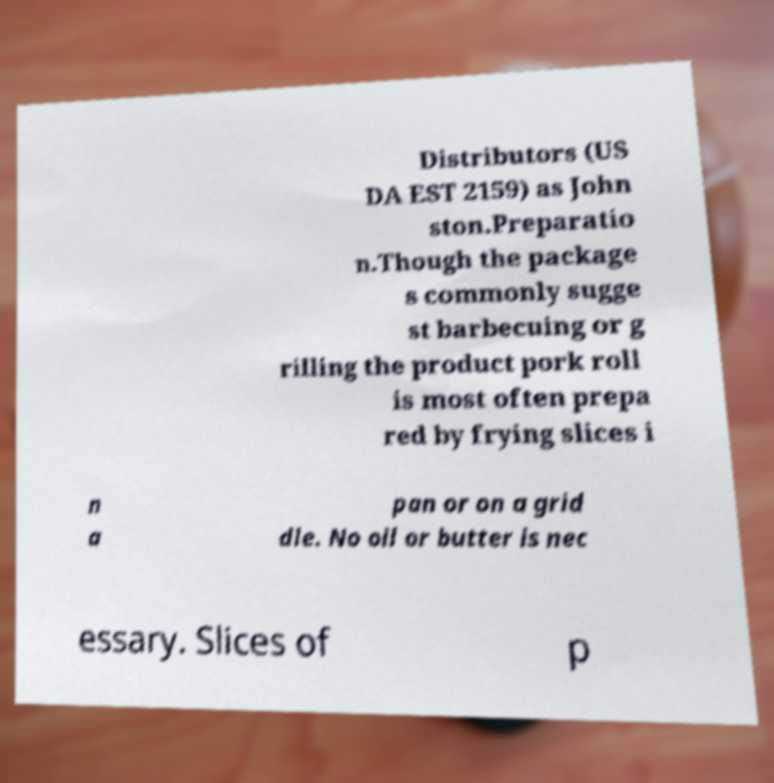Please read and relay the text visible in this image. What does it say? Distributors (US DA EST 2159) as John ston.Preparatio n.Though the package s commonly sugge st barbecuing or g rilling the product pork roll is most often prepa red by frying slices i n a pan or on a grid dle. No oil or butter is nec essary. Slices of p 